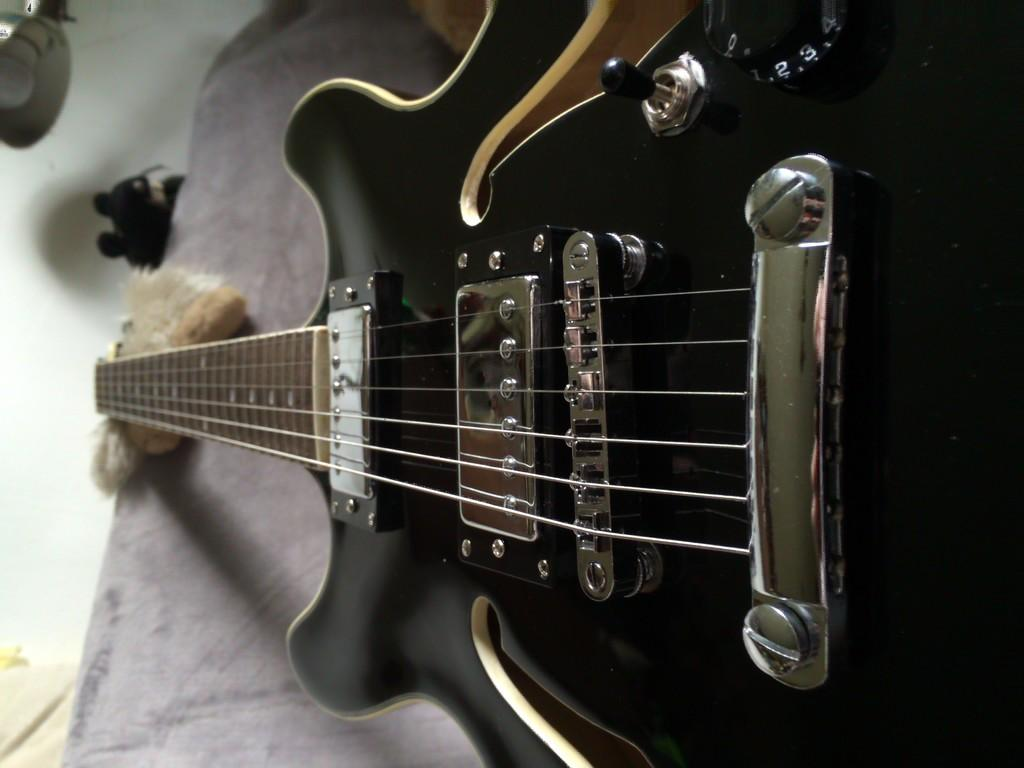What type of musical instrument is in the image? There is a guitar with strings in the image. What other items can be seen in the image besides the guitar? There are toys and some objects in the image. What sense do the snails in the image use to navigate the holiday decorations? There are no snails or holiday decorations present in the image. 